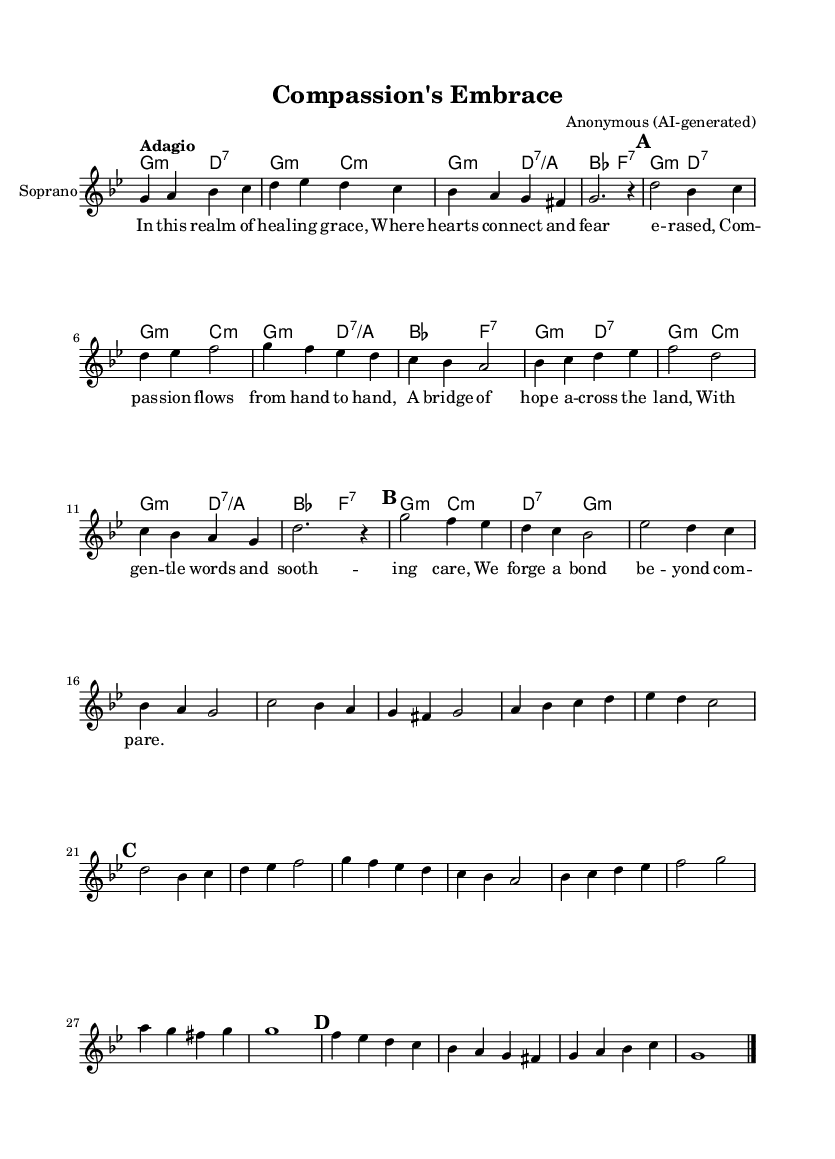What is the key signature of this music? The key signature indicated at the beginning of the score shows one flat, which is characteristic of G minor.
Answer: G minor What is the time signature of this piece? The time signature displayed at the beginning of the score is 4/4, which means there are four beats in each measure.
Answer: 4/4 What is the tempo marking for this piece? The tempo marking at the beginning reads "Adagio," indicating a slow tempo, typically around 66-76 beats per minute.
Answer: Adagio How many sections are in this aria? The sheet music comprises three main sections (A, B, A'), with a coda at the end, resulting in four distinct parts.
Answer: Four What do the lyrics express about emotional connections? The lyrics depict themes of healing grace and compassion, illustrating how these emotions forge strong bonds among people.
Answer: Compassion and healing What musical elements enhance the emotional aspect of this aria? The use of dynamics, the slow tempo, and the lyrical melody contribute to the emotional depth experienced in the aria, typical of Baroque operatic styles.
Answer: Dynamics, tempo, melody What is the primary harmonic structure indicated in this score? The harmonic structure shows a progression typical in Baroque music, using minor chords and seventh chords to create tension and resolution throughout the piece.
Answer: Minor and seventh chords 